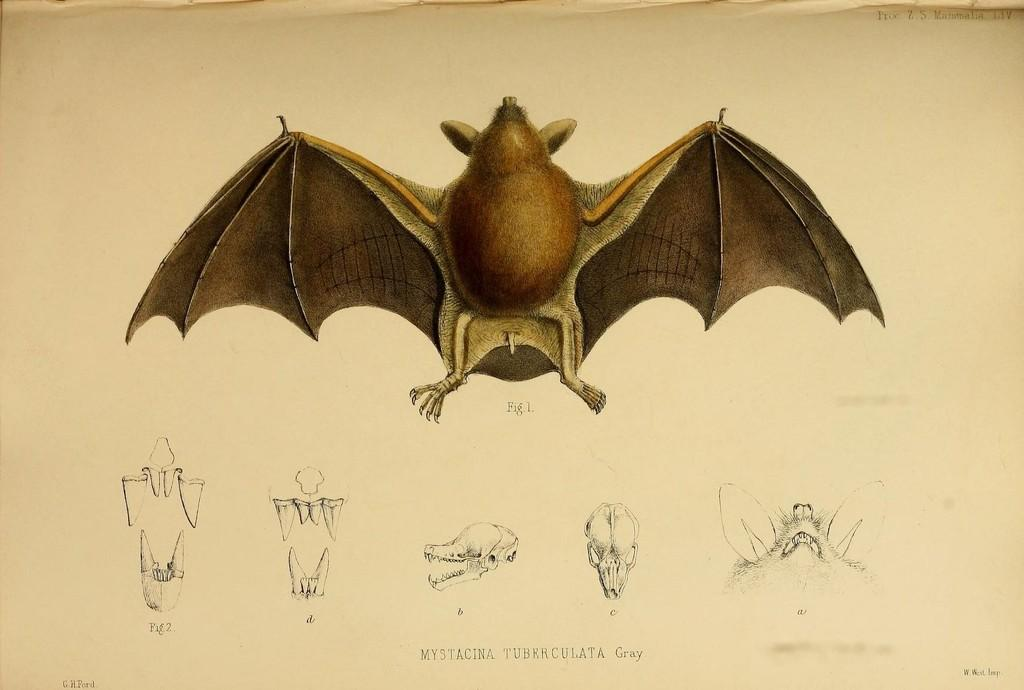What is the main subject of the image? The main subject of the image is a picture of a bat. How is the bat represented in the image? Parts of the bat are printed on the paper. Is there any text in the image? Yes, there is text at the bottom of the image. What type of cheese is being sold at the sign in the image? There is no sign or cheese present in the image; it features a picture of a bat with text at the bottom. 